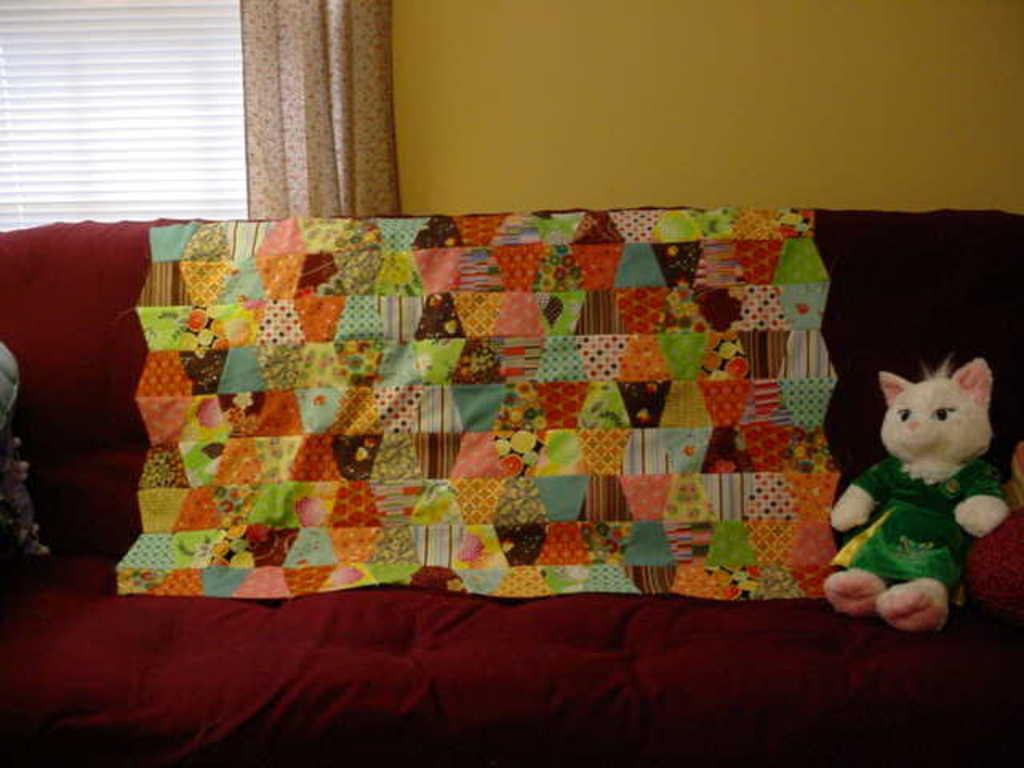How would you summarize this image in a sentence or two? In this picture we can see doll and objects on sofa. In the background of the image we can see wall, curtain and window blind. 